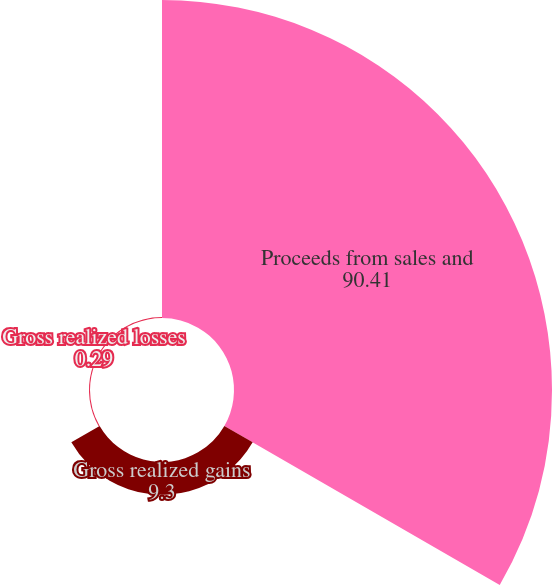<chart> <loc_0><loc_0><loc_500><loc_500><pie_chart><fcel>Proceeds from sales and<fcel>Gross realized gains<fcel>Gross realized losses<nl><fcel>90.41%<fcel>9.3%<fcel>0.29%<nl></chart> 